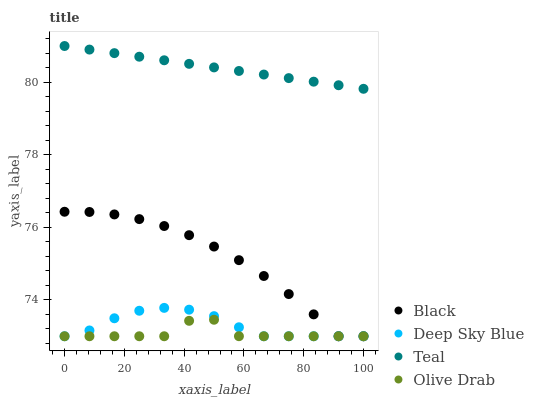Does Olive Drab have the minimum area under the curve?
Answer yes or no. Yes. Does Teal have the maximum area under the curve?
Answer yes or no. Yes. Does Black have the minimum area under the curve?
Answer yes or no. No. Does Black have the maximum area under the curve?
Answer yes or no. No. Is Teal the smoothest?
Answer yes or no. Yes. Is Olive Drab the roughest?
Answer yes or no. Yes. Is Black the smoothest?
Answer yes or no. No. Is Black the roughest?
Answer yes or no. No. Does Olive Drab have the lowest value?
Answer yes or no. Yes. Does Teal have the lowest value?
Answer yes or no. No. Does Teal have the highest value?
Answer yes or no. Yes. Does Black have the highest value?
Answer yes or no. No. Is Deep Sky Blue less than Teal?
Answer yes or no. Yes. Is Teal greater than Deep Sky Blue?
Answer yes or no. Yes. Does Olive Drab intersect Black?
Answer yes or no. Yes. Is Olive Drab less than Black?
Answer yes or no. No. Is Olive Drab greater than Black?
Answer yes or no. No. Does Deep Sky Blue intersect Teal?
Answer yes or no. No. 